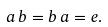Convert formula to latex. <formula><loc_0><loc_0><loc_500><loc_500>a \, b = b \, a = e .</formula> 